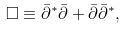Convert formula to latex. <formula><loc_0><loc_0><loc_500><loc_500>\square \equiv \bar { \partial } ^ { * } \bar { \partial } + \bar { \partial } \bar { \partial } ^ { * } ,</formula> 